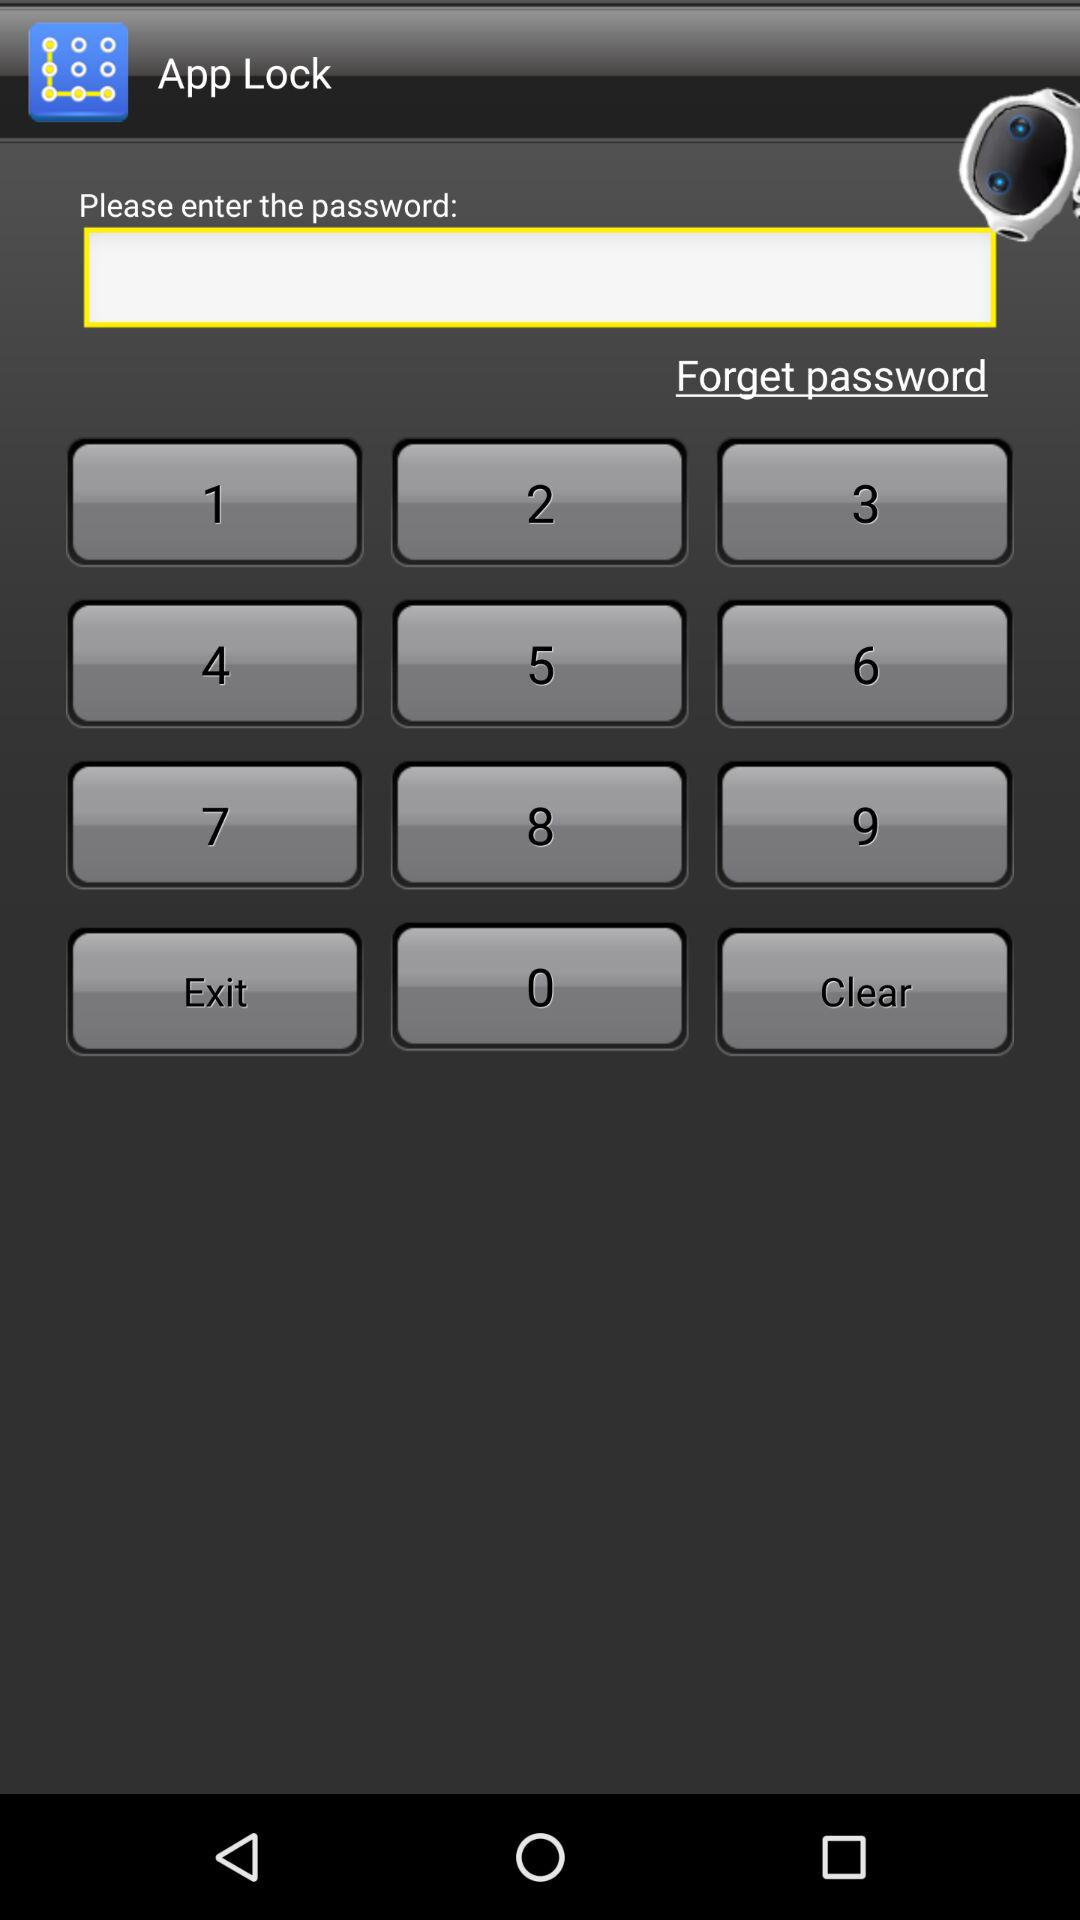What is the name of the application? The name of the location is "App Lock". 